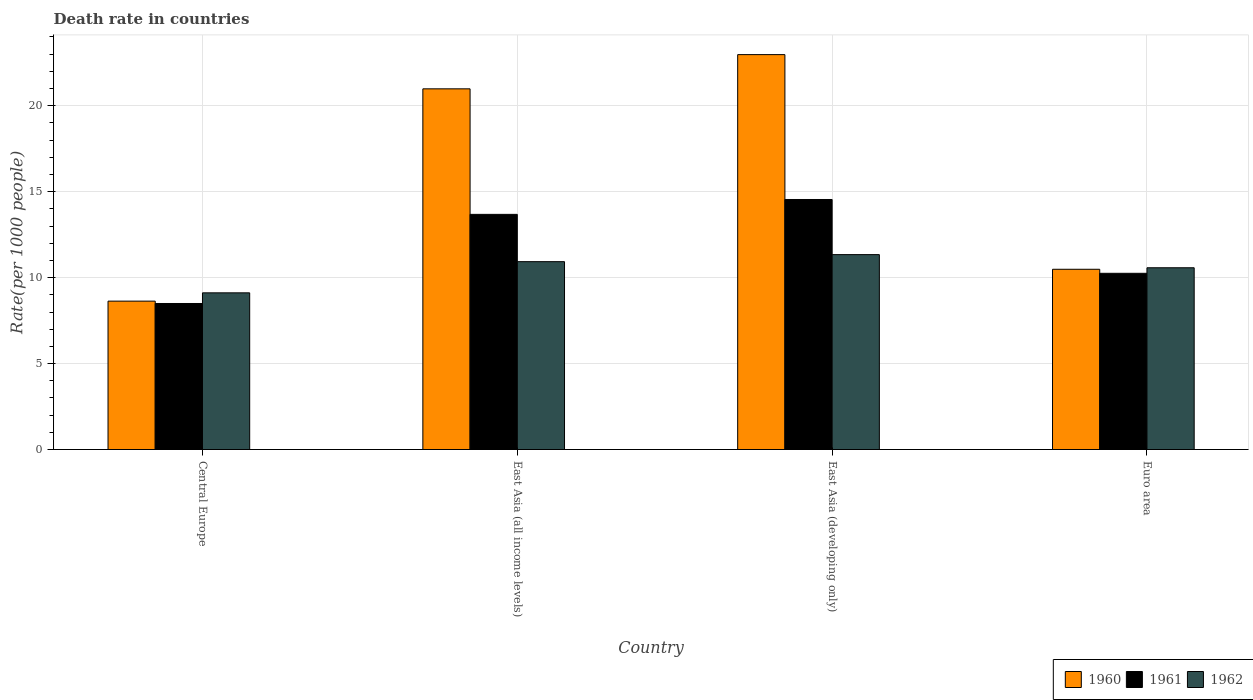How many different coloured bars are there?
Ensure brevity in your answer.  3. How many groups of bars are there?
Your answer should be very brief. 4. Are the number of bars per tick equal to the number of legend labels?
Provide a succinct answer. Yes. Are the number of bars on each tick of the X-axis equal?
Keep it short and to the point. Yes. How many bars are there on the 2nd tick from the left?
Your response must be concise. 3. What is the label of the 1st group of bars from the left?
Your answer should be compact. Central Europe. In how many cases, is the number of bars for a given country not equal to the number of legend labels?
Ensure brevity in your answer.  0. What is the death rate in 1962 in Central Europe?
Make the answer very short. 9.11. Across all countries, what is the maximum death rate in 1961?
Give a very brief answer. 14.55. Across all countries, what is the minimum death rate in 1960?
Your answer should be very brief. 8.63. In which country was the death rate in 1961 maximum?
Offer a terse response. East Asia (developing only). In which country was the death rate in 1962 minimum?
Make the answer very short. Central Europe. What is the total death rate in 1960 in the graph?
Offer a very short reply. 63.07. What is the difference between the death rate in 1961 in East Asia (all income levels) and that in Euro area?
Offer a terse response. 3.43. What is the difference between the death rate in 1960 in East Asia (all income levels) and the death rate in 1962 in Euro area?
Give a very brief answer. 10.41. What is the average death rate in 1960 per country?
Give a very brief answer. 15.77. What is the difference between the death rate of/in 1962 and death rate of/in 1961 in Central Europe?
Your answer should be very brief. 0.62. In how many countries, is the death rate in 1962 greater than 20?
Offer a very short reply. 0. What is the ratio of the death rate in 1962 in East Asia (all income levels) to that in East Asia (developing only)?
Your answer should be very brief. 0.96. Is the difference between the death rate in 1962 in Central Europe and East Asia (all income levels) greater than the difference between the death rate in 1961 in Central Europe and East Asia (all income levels)?
Provide a short and direct response. Yes. What is the difference between the highest and the second highest death rate in 1961?
Give a very brief answer. -3.43. What is the difference between the highest and the lowest death rate in 1961?
Offer a very short reply. 6.05. Is the sum of the death rate in 1960 in East Asia (developing only) and Euro area greater than the maximum death rate in 1961 across all countries?
Provide a succinct answer. Yes. What does the 1st bar from the left in Central Europe represents?
Your response must be concise. 1960. How many bars are there?
Provide a short and direct response. 12. What is the difference between two consecutive major ticks on the Y-axis?
Your answer should be very brief. 5. Are the values on the major ticks of Y-axis written in scientific E-notation?
Provide a short and direct response. No. Where does the legend appear in the graph?
Keep it short and to the point. Bottom right. How are the legend labels stacked?
Ensure brevity in your answer.  Horizontal. What is the title of the graph?
Offer a terse response. Death rate in countries. What is the label or title of the Y-axis?
Your answer should be compact. Rate(per 1000 people). What is the Rate(per 1000 people) of 1960 in Central Europe?
Give a very brief answer. 8.63. What is the Rate(per 1000 people) in 1961 in Central Europe?
Keep it short and to the point. 8.5. What is the Rate(per 1000 people) in 1962 in Central Europe?
Your answer should be compact. 9.11. What is the Rate(per 1000 people) in 1960 in East Asia (all income levels)?
Ensure brevity in your answer.  20.98. What is the Rate(per 1000 people) of 1961 in East Asia (all income levels)?
Keep it short and to the point. 13.68. What is the Rate(per 1000 people) of 1962 in East Asia (all income levels)?
Keep it short and to the point. 10.93. What is the Rate(per 1000 people) of 1960 in East Asia (developing only)?
Offer a terse response. 22.97. What is the Rate(per 1000 people) in 1961 in East Asia (developing only)?
Give a very brief answer. 14.55. What is the Rate(per 1000 people) in 1962 in East Asia (developing only)?
Your answer should be compact. 11.34. What is the Rate(per 1000 people) of 1960 in Euro area?
Your answer should be compact. 10.49. What is the Rate(per 1000 people) in 1961 in Euro area?
Your answer should be compact. 10.25. What is the Rate(per 1000 people) of 1962 in Euro area?
Offer a terse response. 10.57. Across all countries, what is the maximum Rate(per 1000 people) of 1960?
Provide a succinct answer. 22.97. Across all countries, what is the maximum Rate(per 1000 people) in 1961?
Your response must be concise. 14.55. Across all countries, what is the maximum Rate(per 1000 people) in 1962?
Your answer should be very brief. 11.34. Across all countries, what is the minimum Rate(per 1000 people) of 1960?
Make the answer very short. 8.63. Across all countries, what is the minimum Rate(per 1000 people) in 1961?
Offer a very short reply. 8.5. Across all countries, what is the minimum Rate(per 1000 people) in 1962?
Your response must be concise. 9.11. What is the total Rate(per 1000 people) of 1960 in the graph?
Your answer should be compact. 63.07. What is the total Rate(per 1000 people) in 1961 in the graph?
Provide a succinct answer. 46.97. What is the total Rate(per 1000 people) in 1962 in the graph?
Your response must be concise. 41.96. What is the difference between the Rate(per 1000 people) in 1960 in Central Europe and that in East Asia (all income levels)?
Keep it short and to the point. -12.35. What is the difference between the Rate(per 1000 people) of 1961 in Central Europe and that in East Asia (all income levels)?
Offer a terse response. -5.19. What is the difference between the Rate(per 1000 people) of 1962 in Central Europe and that in East Asia (all income levels)?
Provide a short and direct response. -1.81. What is the difference between the Rate(per 1000 people) of 1960 in Central Europe and that in East Asia (developing only)?
Offer a very short reply. -14.34. What is the difference between the Rate(per 1000 people) of 1961 in Central Europe and that in East Asia (developing only)?
Your answer should be compact. -6.05. What is the difference between the Rate(per 1000 people) of 1962 in Central Europe and that in East Asia (developing only)?
Your answer should be very brief. -2.22. What is the difference between the Rate(per 1000 people) of 1960 in Central Europe and that in Euro area?
Your answer should be very brief. -1.85. What is the difference between the Rate(per 1000 people) of 1961 in Central Europe and that in Euro area?
Your answer should be compact. -1.76. What is the difference between the Rate(per 1000 people) in 1962 in Central Europe and that in Euro area?
Keep it short and to the point. -1.46. What is the difference between the Rate(per 1000 people) of 1960 in East Asia (all income levels) and that in East Asia (developing only)?
Ensure brevity in your answer.  -1.99. What is the difference between the Rate(per 1000 people) in 1961 in East Asia (all income levels) and that in East Asia (developing only)?
Keep it short and to the point. -0.86. What is the difference between the Rate(per 1000 people) in 1962 in East Asia (all income levels) and that in East Asia (developing only)?
Your answer should be very brief. -0.41. What is the difference between the Rate(per 1000 people) of 1960 in East Asia (all income levels) and that in Euro area?
Your response must be concise. 10.5. What is the difference between the Rate(per 1000 people) of 1961 in East Asia (all income levels) and that in Euro area?
Your answer should be very brief. 3.43. What is the difference between the Rate(per 1000 people) in 1962 in East Asia (all income levels) and that in Euro area?
Your answer should be compact. 0.35. What is the difference between the Rate(per 1000 people) in 1960 in East Asia (developing only) and that in Euro area?
Provide a succinct answer. 12.49. What is the difference between the Rate(per 1000 people) of 1961 in East Asia (developing only) and that in Euro area?
Your response must be concise. 4.29. What is the difference between the Rate(per 1000 people) of 1962 in East Asia (developing only) and that in Euro area?
Offer a very short reply. 0.77. What is the difference between the Rate(per 1000 people) of 1960 in Central Europe and the Rate(per 1000 people) of 1961 in East Asia (all income levels)?
Ensure brevity in your answer.  -5.05. What is the difference between the Rate(per 1000 people) in 1960 in Central Europe and the Rate(per 1000 people) in 1962 in East Asia (all income levels)?
Provide a short and direct response. -2.3. What is the difference between the Rate(per 1000 people) in 1961 in Central Europe and the Rate(per 1000 people) in 1962 in East Asia (all income levels)?
Your answer should be compact. -2.43. What is the difference between the Rate(per 1000 people) in 1960 in Central Europe and the Rate(per 1000 people) in 1961 in East Asia (developing only)?
Your answer should be very brief. -5.91. What is the difference between the Rate(per 1000 people) of 1960 in Central Europe and the Rate(per 1000 people) of 1962 in East Asia (developing only)?
Make the answer very short. -2.71. What is the difference between the Rate(per 1000 people) of 1961 in Central Europe and the Rate(per 1000 people) of 1962 in East Asia (developing only)?
Keep it short and to the point. -2.84. What is the difference between the Rate(per 1000 people) in 1960 in Central Europe and the Rate(per 1000 people) in 1961 in Euro area?
Offer a terse response. -1.62. What is the difference between the Rate(per 1000 people) in 1960 in Central Europe and the Rate(per 1000 people) in 1962 in Euro area?
Provide a succinct answer. -1.94. What is the difference between the Rate(per 1000 people) of 1961 in Central Europe and the Rate(per 1000 people) of 1962 in Euro area?
Provide a short and direct response. -2.08. What is the difference between the Rate(per 1000 people) in 1960 in East Asia (all income levels) and the Rate(per 1000 people) in 1961 in East Asia (developing only)?
Your response must be concise. 6.44. What is the difference between the Rate(per 1000 people) of 1960 in East Asia (all income levels) and the Rate(per 1000 people) of 1962 in East Asia (developing only)?
Make the answer very short. 9.64. What is the difference between the Rate(per 1000 people) of 1961 in East Asia (all income levels) and the Rate(per 1000 people) of 1962 in East Asia (developing only)?
Your answer should be very brief. 2.34. What is the difference between the Rate(per 1000 people) in 1960 in East Asia (all income levels) and the Rate(per 1000 people) in 1961 in Euro area?
Give a very brief answer. 10.73. What is the difference between the Rate(per 1000 people) of 1960 in East Asia (all income levels) and the Rate(per 1000 people) of 1962 in Euro area?
Offer a very short reply. 10.41. What is the difference between the Rate(per 1000 people) in 1961 in East Asia (all income levels) and the Rate(per 1000 people) in 1962 in Euro area?
Ensure brevity in your answer.  3.11. What is the difference between the Rate(per 1000 people) in 1960 in East Asia (developing only) and the Rate(per 1000 people) in 1961 in Euro area?
Your answer should be very brief. 12.72. What is the difference between the Rate(per 1000 people) of 1960 in East Asia (developing only) and the Rate(per 1000 people) of 1962 in Euro area?
Your response must be concise. 12.4. What is the difference between the Rate(per 1000 people) in 1961 in East Asia (developing only) and the Rate(per 1000 people) in 1962 in Euro area?
Your answer should be compact. 3.97. What is the average Rate(per 1000 people) of 1960 per country?
Your answer should be very brief. 15.77. What is the average Rate(per 1000 people) in 1961 per country?
Give a very brief answer. 11.74. What is the average Rate(per 1000 people) of 1962 per country?
Your answer should be very brief. 10.49. What is the difference between the Rate(per 1000 people) in 1960 and Rate(per 1000 people) in 1961 in Central Europe?
Make the answer very short. 0.14. What is the difference between the Rate(per 1000 people) of 1960 and Rate(per 1000 people) of 1962 in Central Europe?
Provide a succinct answer. -0.48. What is the difference between the Rate(per 1000 people) in 1961 and Rate(per 1000 people) in 1962 in Central Europe?
Your answer should be very brief. -0.62. What is the difference between the Rate(per 1000 people) in 1960 and Rate(per 1000 people) in 1961 in East Asia (all income levels)?
Offer a terse response. 7.3. What is the difference between the Rate(per 1000 people) of 1960 and Rate(per 1000 people) of 1962 in East Asia (all income levels)?
Give a very brief answer. 10.05. What is the difference between the Rate(per 1000 people) of 1961 and Rate(per 1000 people) of 1962 in East Asia (all income levels)?
Give a very brief answer. 2.75. What is the difference between the Rate(per 1000 people) of 1960 and Rate(per 1000 people) of 1961 in East Asia (developing only)?
Your answer should be compact. 8.43. What is the difference between the Rate(per 1000 people) of 1960 and Rate(per 1000 people) of 1962 in East Asia (developing only)?
Ensure brevity in your answer.  11.63. What is the difference between the Rate(per 1000 people) in 1961 and Rate(per 1000 people) in 1962 in East Asia (developing only)?
Provide a short and direct response. 3.21. What is the difference between the Rate(per 1000 people) of 1960 and Rate(per 1000 people) of 1961 in Euro area?
Give a very brief answer. 0.23. What is the difference between the Rate(per 1000 people) of 1960 and Rate(per 1000 people) of 1962 in Euro area?
Offer a terse response. -0.09. What is the difference between the Rate(per 1000 people) of 1961 and Rate(per 1000 people) of 1962 in Euro area?
Keep it short and to the point. -0.32. What is the ratio of the Rate(per 1000 people) of 1960 in Central Europe to that in East Asia (all income levels)?
Keep it short and to the point. 0.41. What is the ratio of the Rate(per 1000 people) in 1961 in Central Europe to that in East Asia (all income levels)?
Your answer should be very brief. 0.62. What is the ratio of the Rate(per 1000 people) in 1962 in Central Europe to that in East Asia (all income levels)?
Your answer should be very brief. 0.83. What is the ratio of the Rate(per 1000 people) in 1960 in Central Europe to that in East Asia (developing only)?
Ensure brevity in your answer.  0.38. What is the ratio of the Rate(per 1000 people) in 1961 in Central Europe to that in East Asia (developing only)?
Your response must be concise. 0.58. What is the ratio of the Rate(per 1000 people) of 1962 in Central Europe to that in East Asia (developing only)?
Make the answer very short. 0.8. What is the ratio of the Rate(per 1000 people) in 1960 in Central Europe to that in Euro area?
Offer a terse response. 0.82. What is the ratio of the Rate(per 1000 people) in 1961 in Central Europe to that in Euro area?
Provide a succinct answer. 0.83. What is the ratio of the Rate(per 1000 people) in 1962 in Central Europe to that in Euro area?
Offer a terse response. 0.86. What is the ratio of the Rate(per 1000 people) of 1960 in East Asia (all income levels) to that in East Asia (developing only)?
Provide a short and direct response. 0.91. What is the ratio of the Rate(per 1000 people) in 1961 in East Asia (all income levels) to that in East Asia (developing only)?
Provide a short and direct response. 0.94. What is the ratio of the Rate(per 1000 people) of 1962 in East Asia (all income levels) to that in East Asia (developing only)?
Provide a succinct answer. 0.96. What is the ratio of the Rate(per 1000 people) of 1960 in East Asia (all income levels) to that in Euro area?
Ensure brevity in your answer.  2. What is the ratio of the Rate(per 1000 people) of 1961 in East Asia (all income levels) to that in Euro area?
Give a very brief answer. 1.33. What is the ratio of the Rate(per 1000 people) in 1962 in East Asia (all income levels) to that in Euro area?
Provide a short and direct response. 1.03. What is the ratio of the Rate(per 1000 people) in 1960 in East Asia (developing only) to that in Euro area?
Make the answer very short. 2.19. What is the ratio of the Rate(per 1000 people) in 1961 in East Asia (developing only) to that in Euro area?
Offer a very short reply. 1.42. What is the ratio of the Rate(per 1000 people) of 1962 in East Asia (developing only) to that in Euro area?
Offer a very short reply. 1.07. What is the difference between the highest and the second highest Rate(per 1000 people) in 1960?
Keep it short and to the point. 1.99. What is the difference between the highest and the second highest Rate(per 1000 people) in 1961?
Ensure brevity in your answer.  0.86. What is the difference between the highest and the second highest Rate(per 1000 people) in 1962?
Offer a terse response. 0.41. What is the difference between the highest and the lowest Rate(per 1000 people) of 1960?
Your response must be concise. 14.34. What is the difference between the highest and the lowest Rate(per 1000 people) of 1961?
Your answer should be very brief. 6.05. What is the difference between the highest and the lowest Rate(per 1000 people) of 1962?
Your answer should be compact. 2.22. 